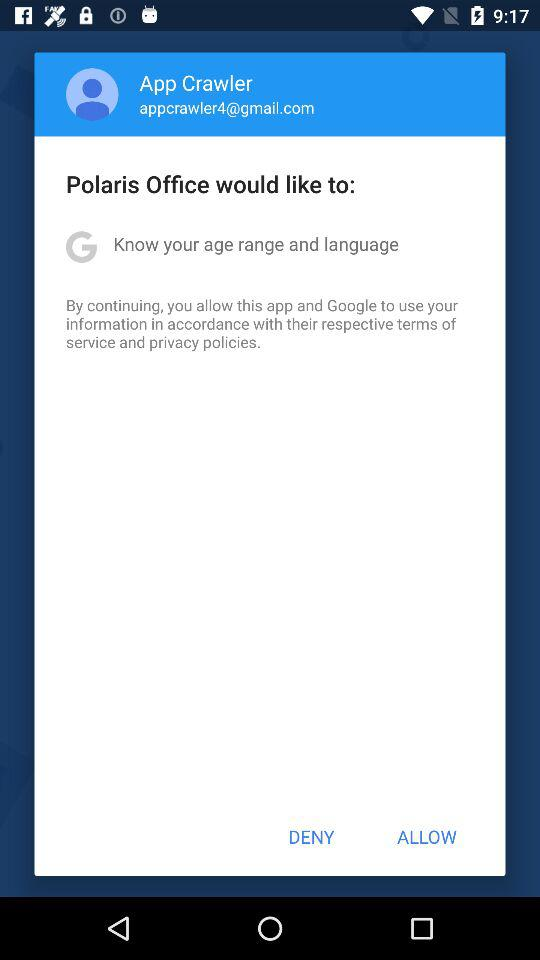What is the email address? The email address is "appcrawler4@gmail.com". 